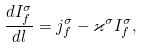<formula> <loc_0><loc_0><loc_500><loc_500>\frac { d I _ { f } ^ { \sigma } } { d l } = j _ { f } ^ { \sigma } - \varkappa ^ { \sigma } I _ { f } ^ { \sigma } ,</formula> 